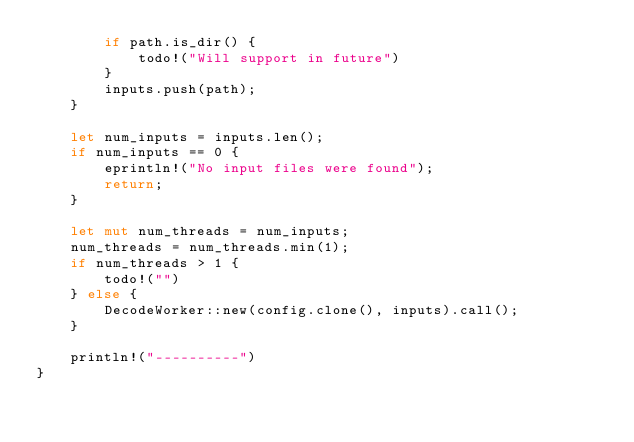Convert code to text. <code><loc_0><loc_0><loc_500><loc_500><_Rust_>        if path.is_dir() {
            todo!("Will support in future")
        }
        inputs.push(path);
    }

    let num_inputs = inputs.len();
    if num_inputs == 0 {
        eprintln!("No input files were found");
        return;
    }

    let mut num_threads = num_inputs;
    num_threads = num_threads.min(1);
    if num_threads > 1 {
        todo!("")
    } else {
        DecodeWorker::new(config.clone(), inputs).call();
    }

    println!("----------")
}
</code> 